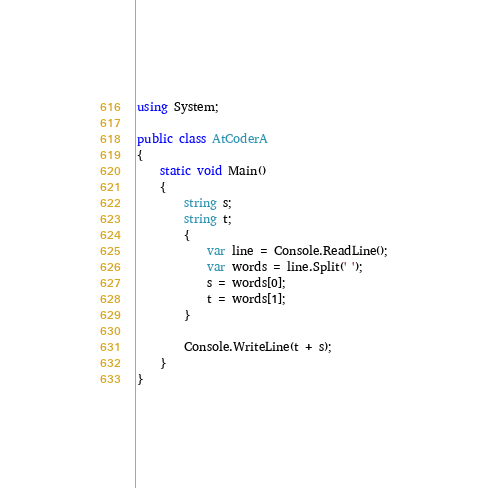Convert code to text. <code><loc_0><loc_0><loc_500><loc_500><_C#_>using System;

public class AtCoderA
{
    static void Main()
    {
        string s;
        string t;
        {
            var line = Console.ReadLine();
            var words = line.Split(' ');
            s = words[0];
            t = words[1];
        }

        Console.WriteLine(t + s);
    }
}</code> 